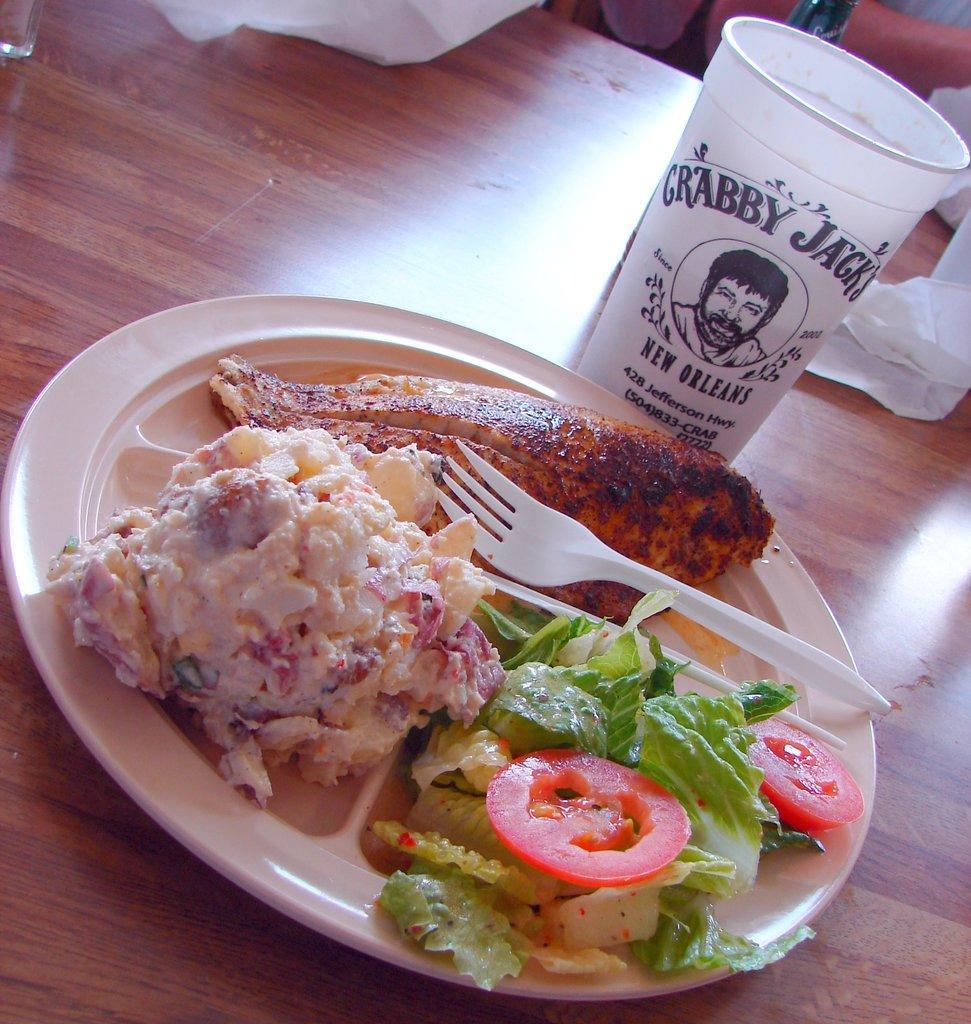Describe this image in one or two sentences. We can see plate with food,fork,glass and tissue papers on the table. 